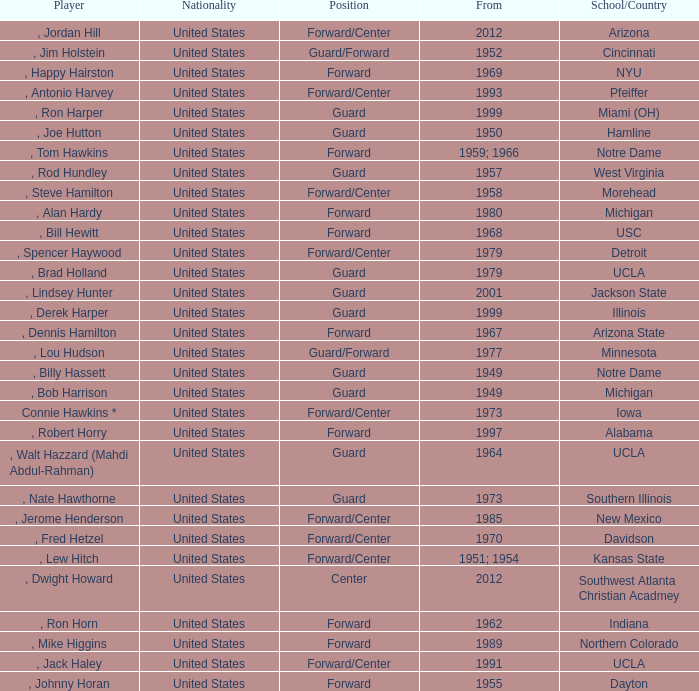What position was for Arizona State? Forward. 